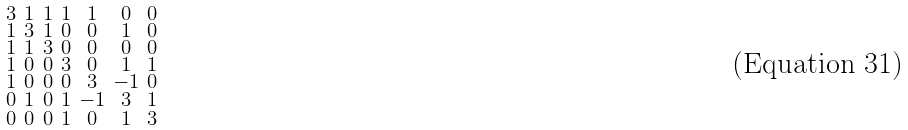<formula> <loc_0><loc_0><loc_500><loc_500>\begin{smallmatrix} 3 & 1 & 1 & 1 & 1 & 0 & 0 \\ 1 & 3 & 1 & 0 & 0 & 1 & 0 \\ 1 & 1 & 3 & 0 & 0 & 0 & 0 \\ 1 & 0 & 0 & 3 & 0 & 1 & 1 \\ 1 & 0 & 0 & 0 & 3 & - 1 & 0 \\ 0 & 1 & 0 & 1 & - 1 & 3 & 1 \\ 0 & 0 & 0 & 1 & 0 & 1 & 3 \end{smallmatrix}</formula> 